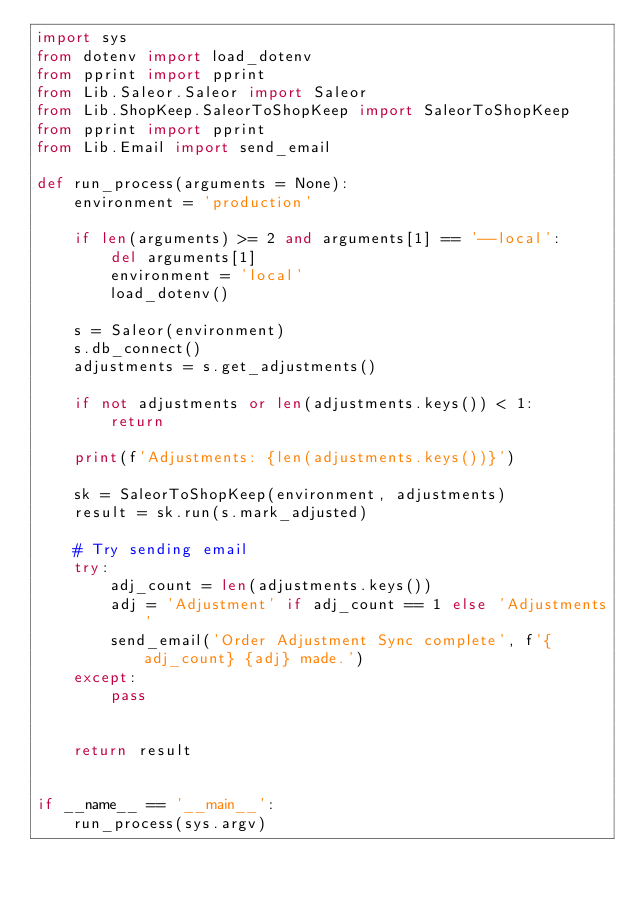<code> <loc_0><loc_0><loc_500><loc_500><_Python_>import sys
from dotenv import load_dotenv
from pprint import pprint
from Lib.Saleor.Saleor import Saleor
from Lib.ShopKeep.SaleorToShopKeep import SaleorToShopKeep
from pprint import pprint
from Lib.Email import send_email

def run_process(arguments = None):
    environment = 'production'

    if len(arguments) >= 2 and arguments[1] == '--local':
        del arguments[1]
        environment = 'local'
        load_dotenv()

    s = Saleor(environment)
    s.db_connect()
    adjustments = s.get_adjustments()

    if not adjustments or len(adjustments.keys()) < 1:
        return

    print(f'Adjustments: {len(adjustments.keys())}')

    sk = SaleorToShopKeep(environment, adjustments)
    result = sk.run(s.mark_adjusted)

    # Try sending email
    try:
        adj_count = len(adjustments.keys())
        adj = 'Adjustment' if adj_count == 1 else 'Adjustments'
        send_email('Order Adjustment Sync complete', f'{adj_count} {adj} made.')
    except:
        pass


    return result


if __name__ == '__main__':
    run_process(sys.argv)
</code> 